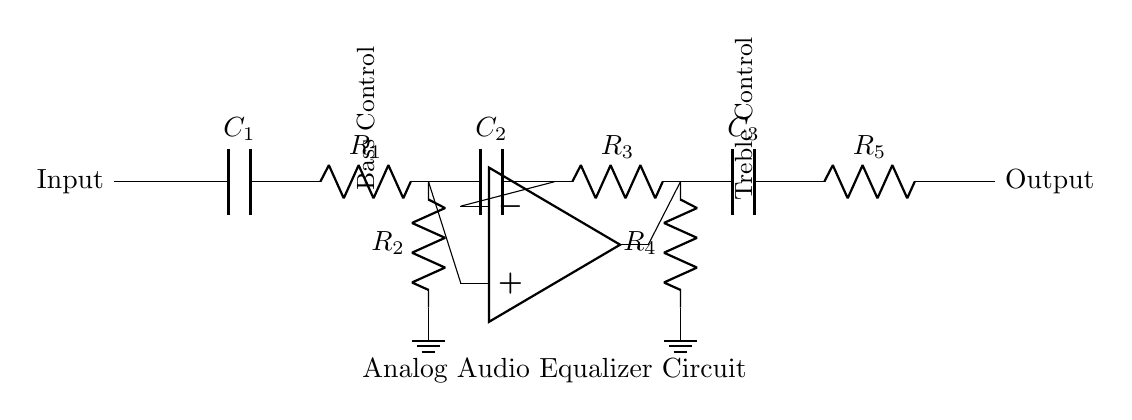What is the component type for C1? C1 is a capacitor, which is indicated by the label C next to the component symbol in the circuit diagram.
Answer: capacitor How many resistors are in the circuit? The circuit includes five resistors (R1, R2, R3, R4, R5), which can be counted directly from the labels on the circuit diagram.
Answer: five What is the function of the op-amp in this circuit? The op-amp serves to amplify the audio signal and is connected to the bass and treble controls, facilitating adjustments in audio output levels.
Answer: amplification Where is the treble control located in the circuit? The treble control is located between R3 and R4, and it is designated clearly in the circuit with a label that states "Treble Control."
Answer: between R3 and R4 What is the output connection symbol? The output connection is represented by a short line at the end of the circuit with "Output" labeled next to it, indicating where the processed audio signal exits the circuit.
Answer: short line Which capacitors are used for bass and treble? C2 is used for bass enhancement, and C3 is for treble enhancement, as indicated by their respective positions and labels in the circuit.
Answer: C2 and C3 